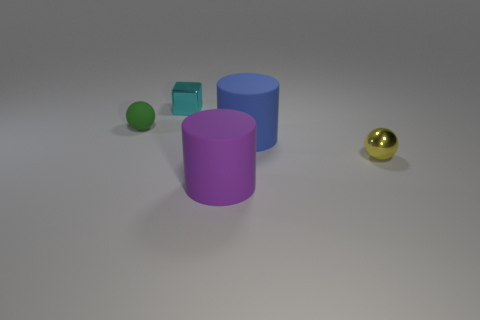What number of purple cylinders have the same material as the small green ball?
Your answer should be compact. 1. How many shiny objects are either small red cylinders or blue cylinders?
Provide a succinct answer. 0. There is a metallic thing that is in front of the cyan metallic object; is it the same shape as the shiny object that is behind the small matte sphere?
Offer a very short reply. No. What is the color of the thing that is to the left of the yellow thing and right of the purple thing?
Make the answer very short. Blue. There is a sphere that is behind the metallic sphere; does it have the same size as the metal object that is in front of the tiny green thing?
Your response must be concise. Yes. What number of small matte things have the same color as the tiny cube?
Provide a succinct answer. 0. How many large things are matte cylinders or brown matte cylinders?
Provide a succinct answer. 2. Do the big object that is behind the purple cylinder and the tiny yellow object have the same material?
Your response must be concise. No. The big rubber cylinder to the right of the purple thing is what color?
Ensure brevity in your answer.  Blue. Are there any green shiny balls of the same size as the blue thing?
Your answer should be very brief. No. 